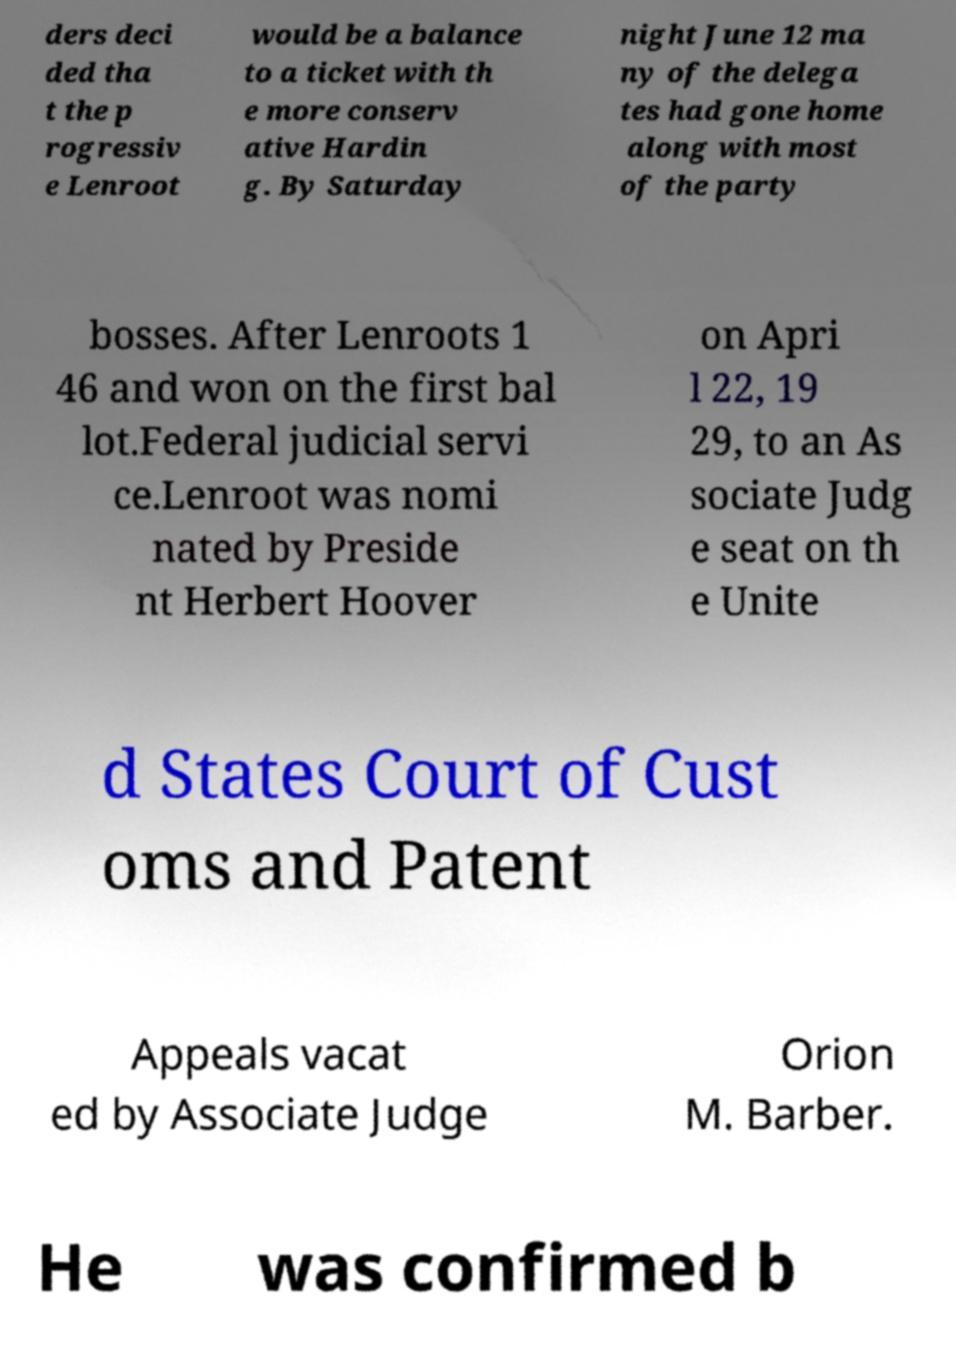Could you assist in decoding the text presented in this image and type it out clearly? ders deci ded tha t the p rogressiv e Lenroot would be a balance to a ticket with th e more conserv ative Hardin g. By Saturday night June 12 ma ny of the delega tes had gone home along with most of the party bosses. After Lenroots 1 46 and won on the first bal lot.Federal judicial servi ce.Lenroot was nomi nated by Preside nt Herbert Hoover on Apri l 22, 19 29, to an As sociate Judg e seat on th e Unite d States Court of Cust oms and Patent Appeals vacat ed by Associate Judge Orion M. Barber. He was confirmed b 